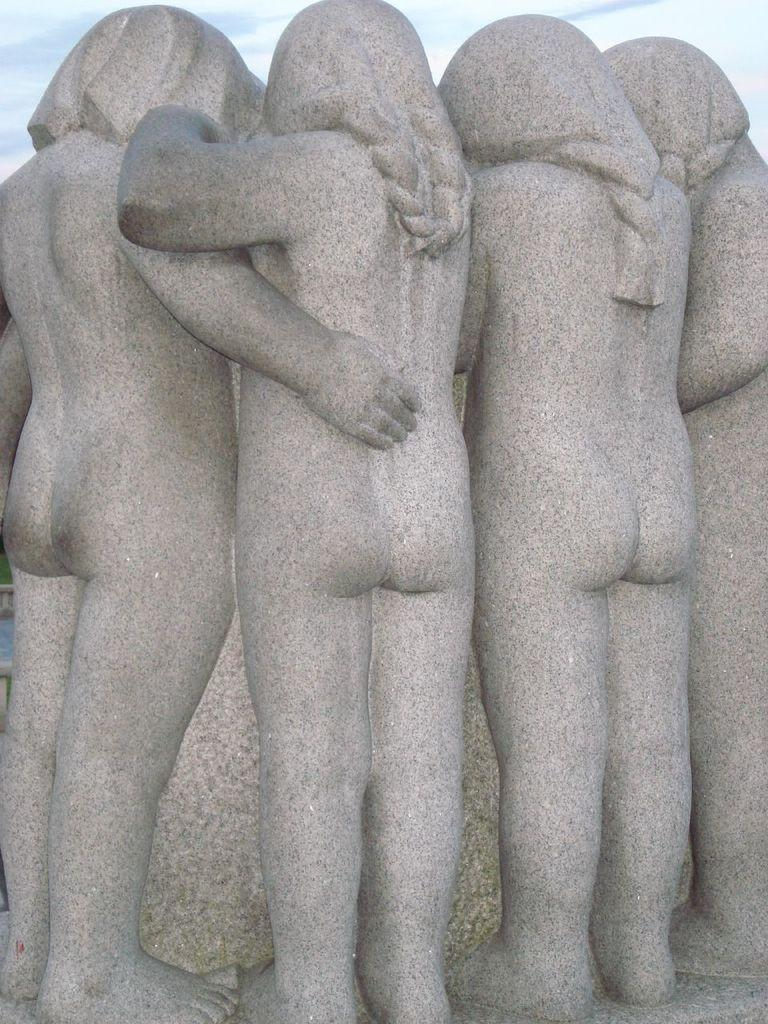What type of objects can be seen in the image? There are statues in the image. What is the price of the rail system depicted in the image? There is no rail system present in the image; it only features statues. 